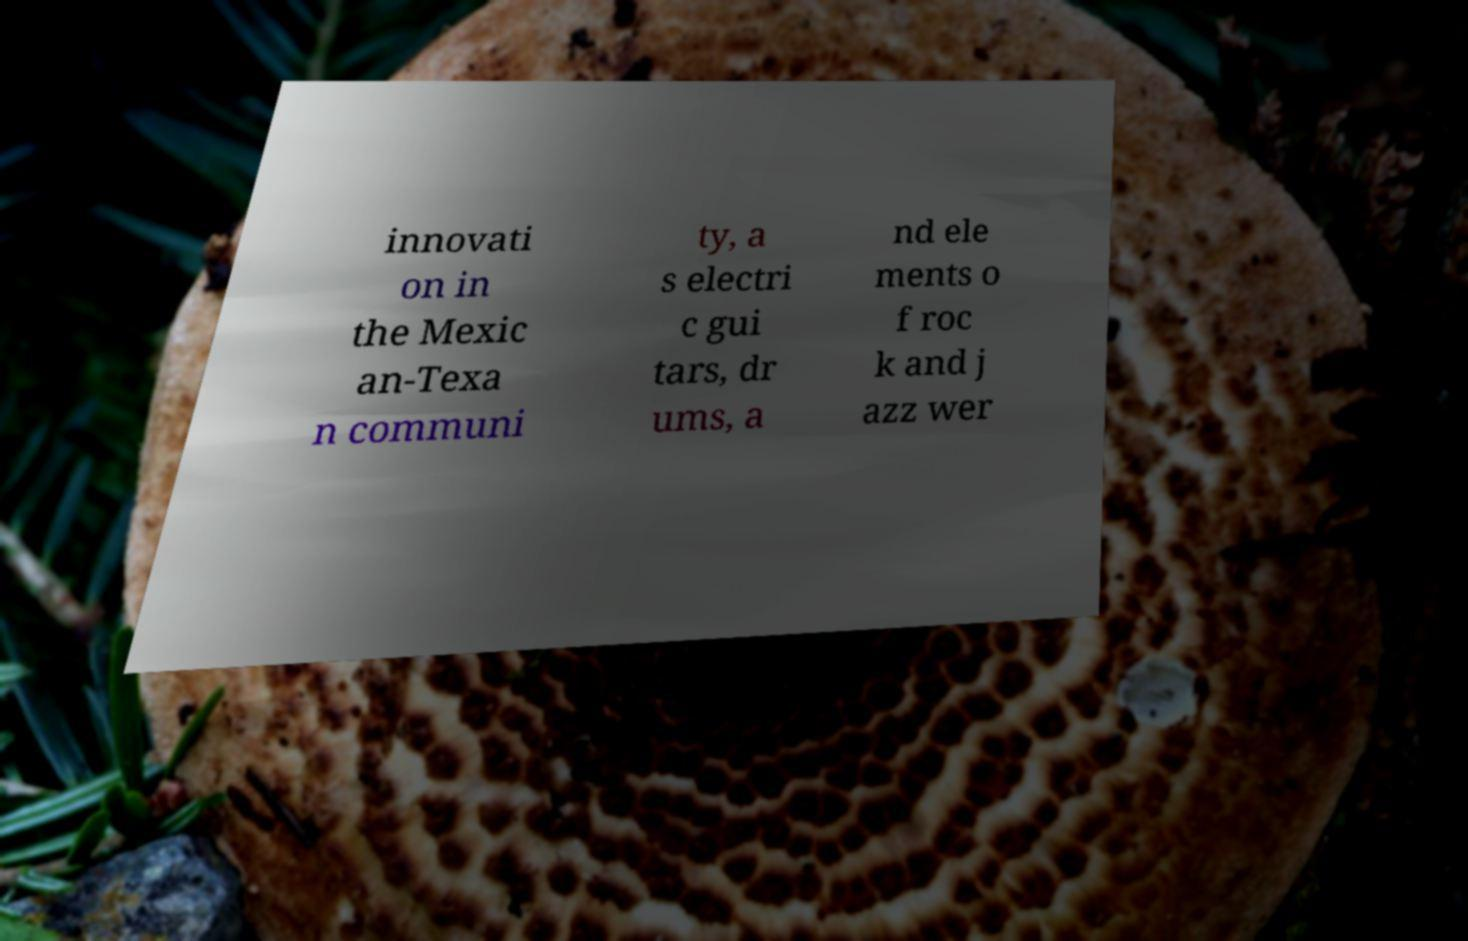Could you extract and type out the text from this image? innovati on in the Mexic an-Texa n communi ty, a s electri c gui tars, dr ums, a nd ele ments o f roc k and j azz wer 